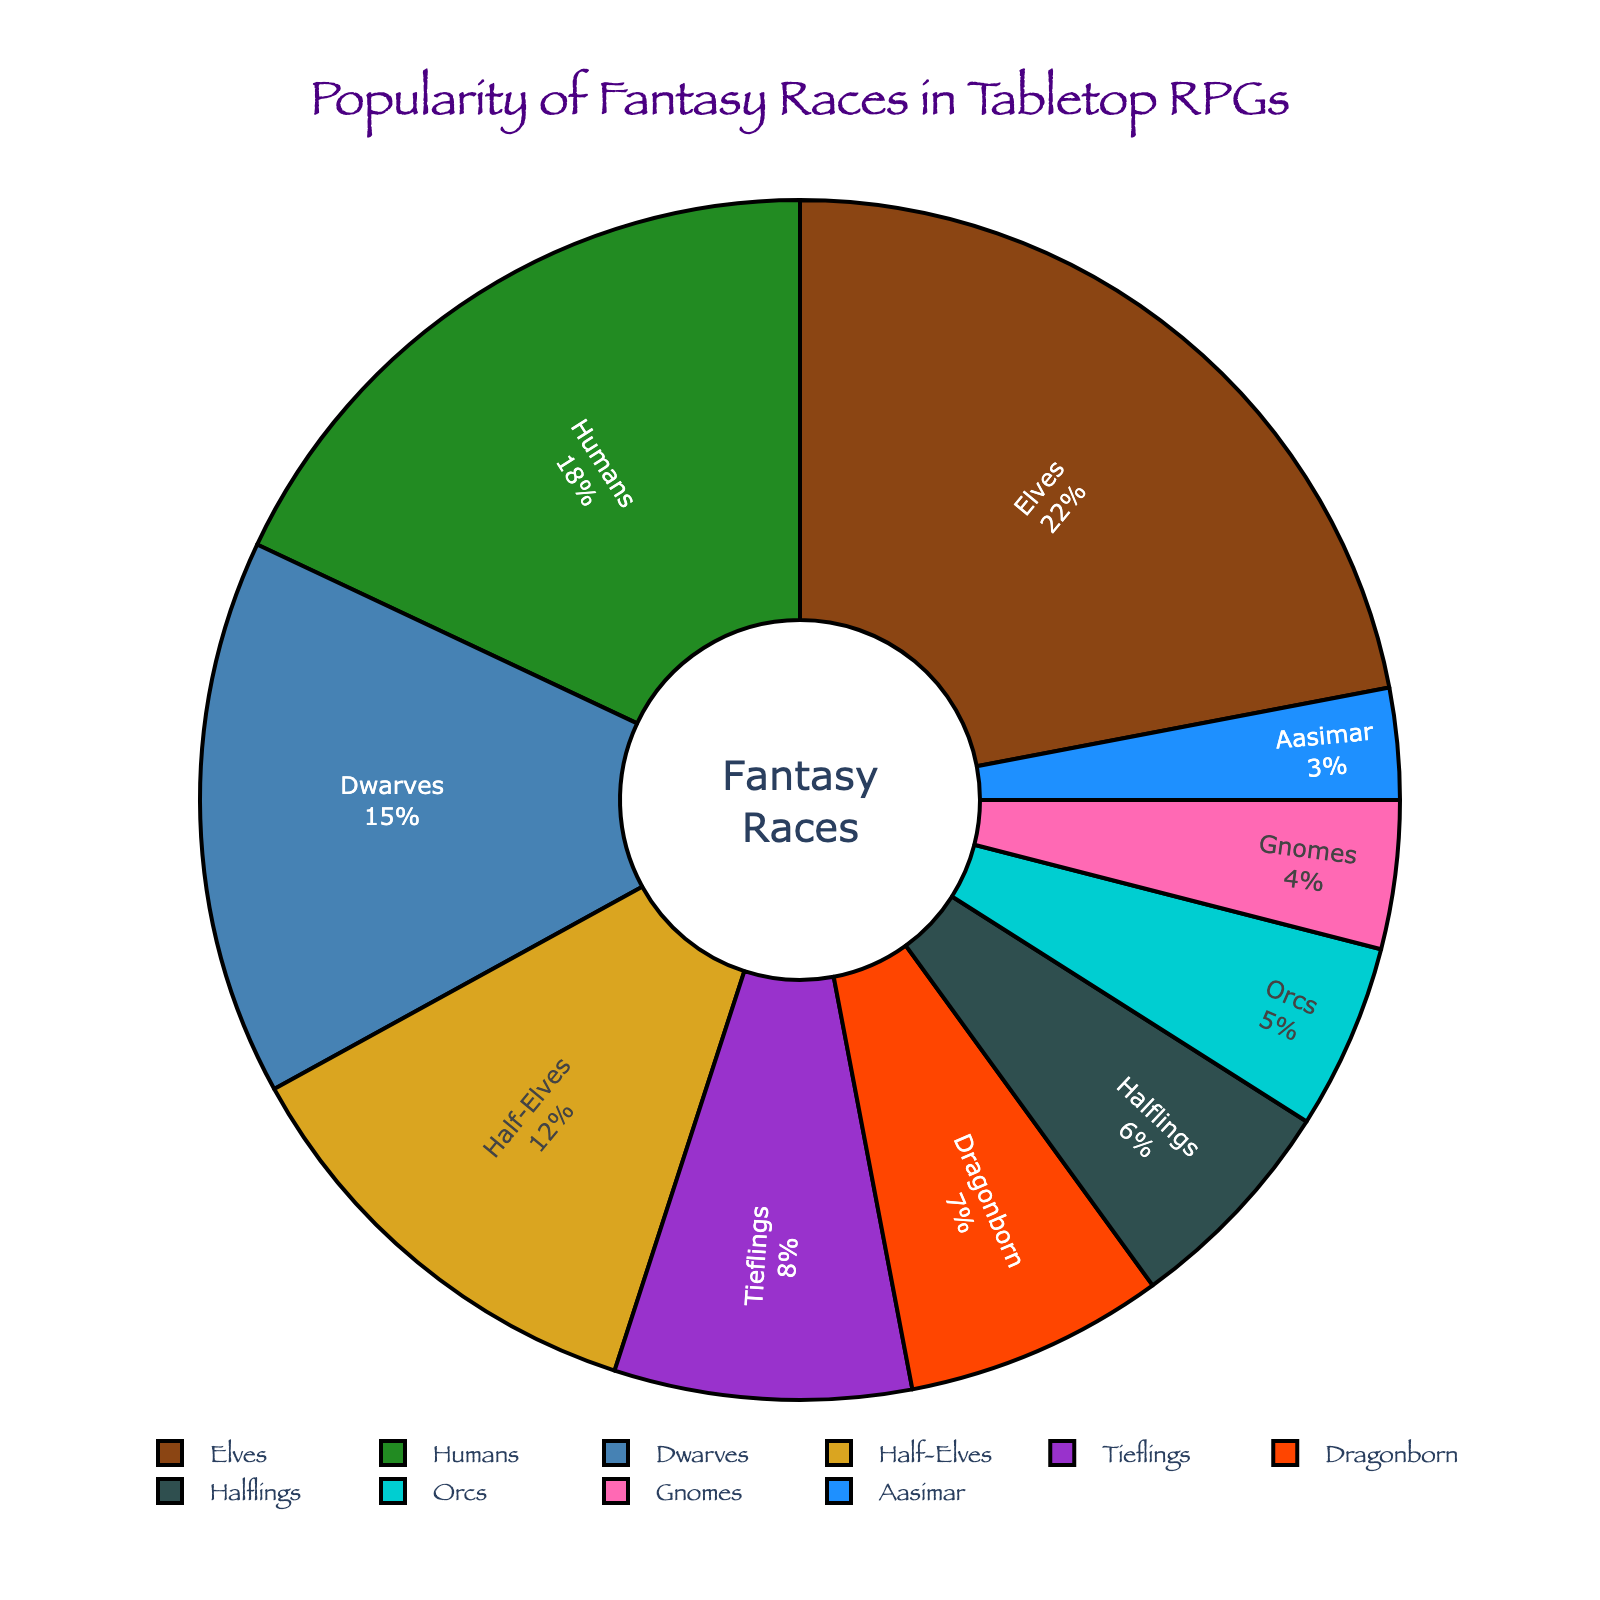What is the most popular fantasy race among tabletop RPG players? The pie chart shows the percentage for each fantasy race. The race with the largest percentage is the most popular.
Answer: Elves Which race has a higher percentage: Tieflings or Half-Elves? The pie chart shows that Tieflings have 8% and Half-Elves have 12%. Since 12% is greater than 8%, Half-Elves have a higher percentage.
Answer: Half-Elves How many races have a percentage below 10%? From the pie chart, identify each race's percentage and count those below 10%. The races are Tieflings (8%), Dragonborn (7%), Halflings (6%), Orcs (5%), Gnomes (4%), and Aasimar (3%).
Answer: 6 What is the combined percentage of Elves and Humans? Add the percentages of Elves (22%) and Humans (18%) from the pie chart. 22 + 18 = 40.
Answer: 40% Is the percentage of Gnomes more than half of the percentage of Dwarves? The pie chart shows Gnomes at 4% and Dwarves at 15%. Half of Dwarves' percentage is 15 / 2 = 7.5%. Since 4% is less than 7.5%, Gnomes' percentage is not more than half of Dwarves'.
Answer: No Which race has the lowest percentage? The pie chart indicates the percentage for each race. The race with the smallest percentage is the one with the lowest value.
Answer: Aasimar What is the difference in popularity between Elves and Halflings? Subtract the percentage of Halflings (6%) from the percentage of Elves (22%), 22 - 6 = 16.
Answer: 16% What is the average percentage of the four least popular races? Identify the four races with the lowest percentages: Gnomes (4%), Aasimar (3%), Orcs (5%), and Halflings (6%). Sum these percentages and divide by 4: (4 + 3 + 5 + 6) / 4 = 18 / 4 = 4.5.
Answer: 4.5% Which race is represented by a golden color in the pie chart? According to the custom color palette, gold corresponds to the fourth color. The fourth race by the pie chart's sequence is Half-Elves.
Answer: Half-Elves What is the relationship between the percentages of Dragonborn and Orcs? Dragonborn have a percentage of 7% and Orcs have 5%. Thus, Dragonborn have a higher percentage than Orcs.
Answer: Dragonborn > Orcs 